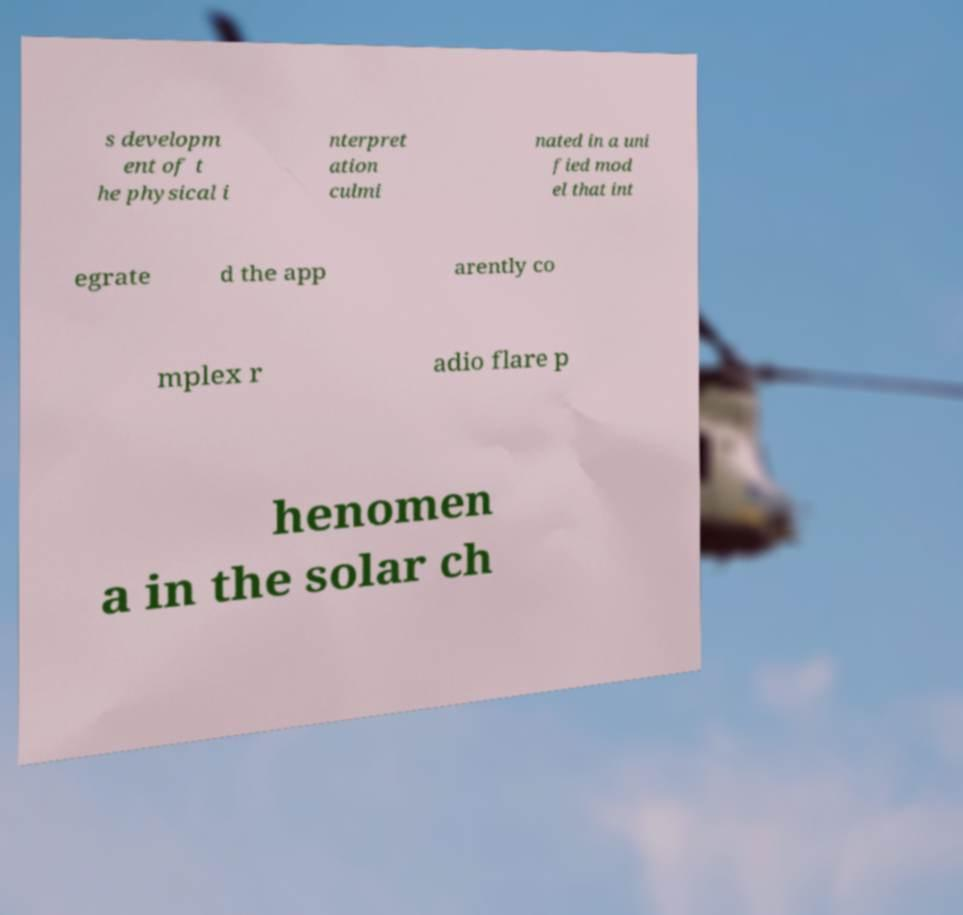What messages or text are displayed in this image? I need them in a readable, typed format. s developm ent of t he physical i nterpret ation culmi nated in a uni fied mod el that int egrate d the app arently co mplex r adio flare p henomen a in the solar ch 